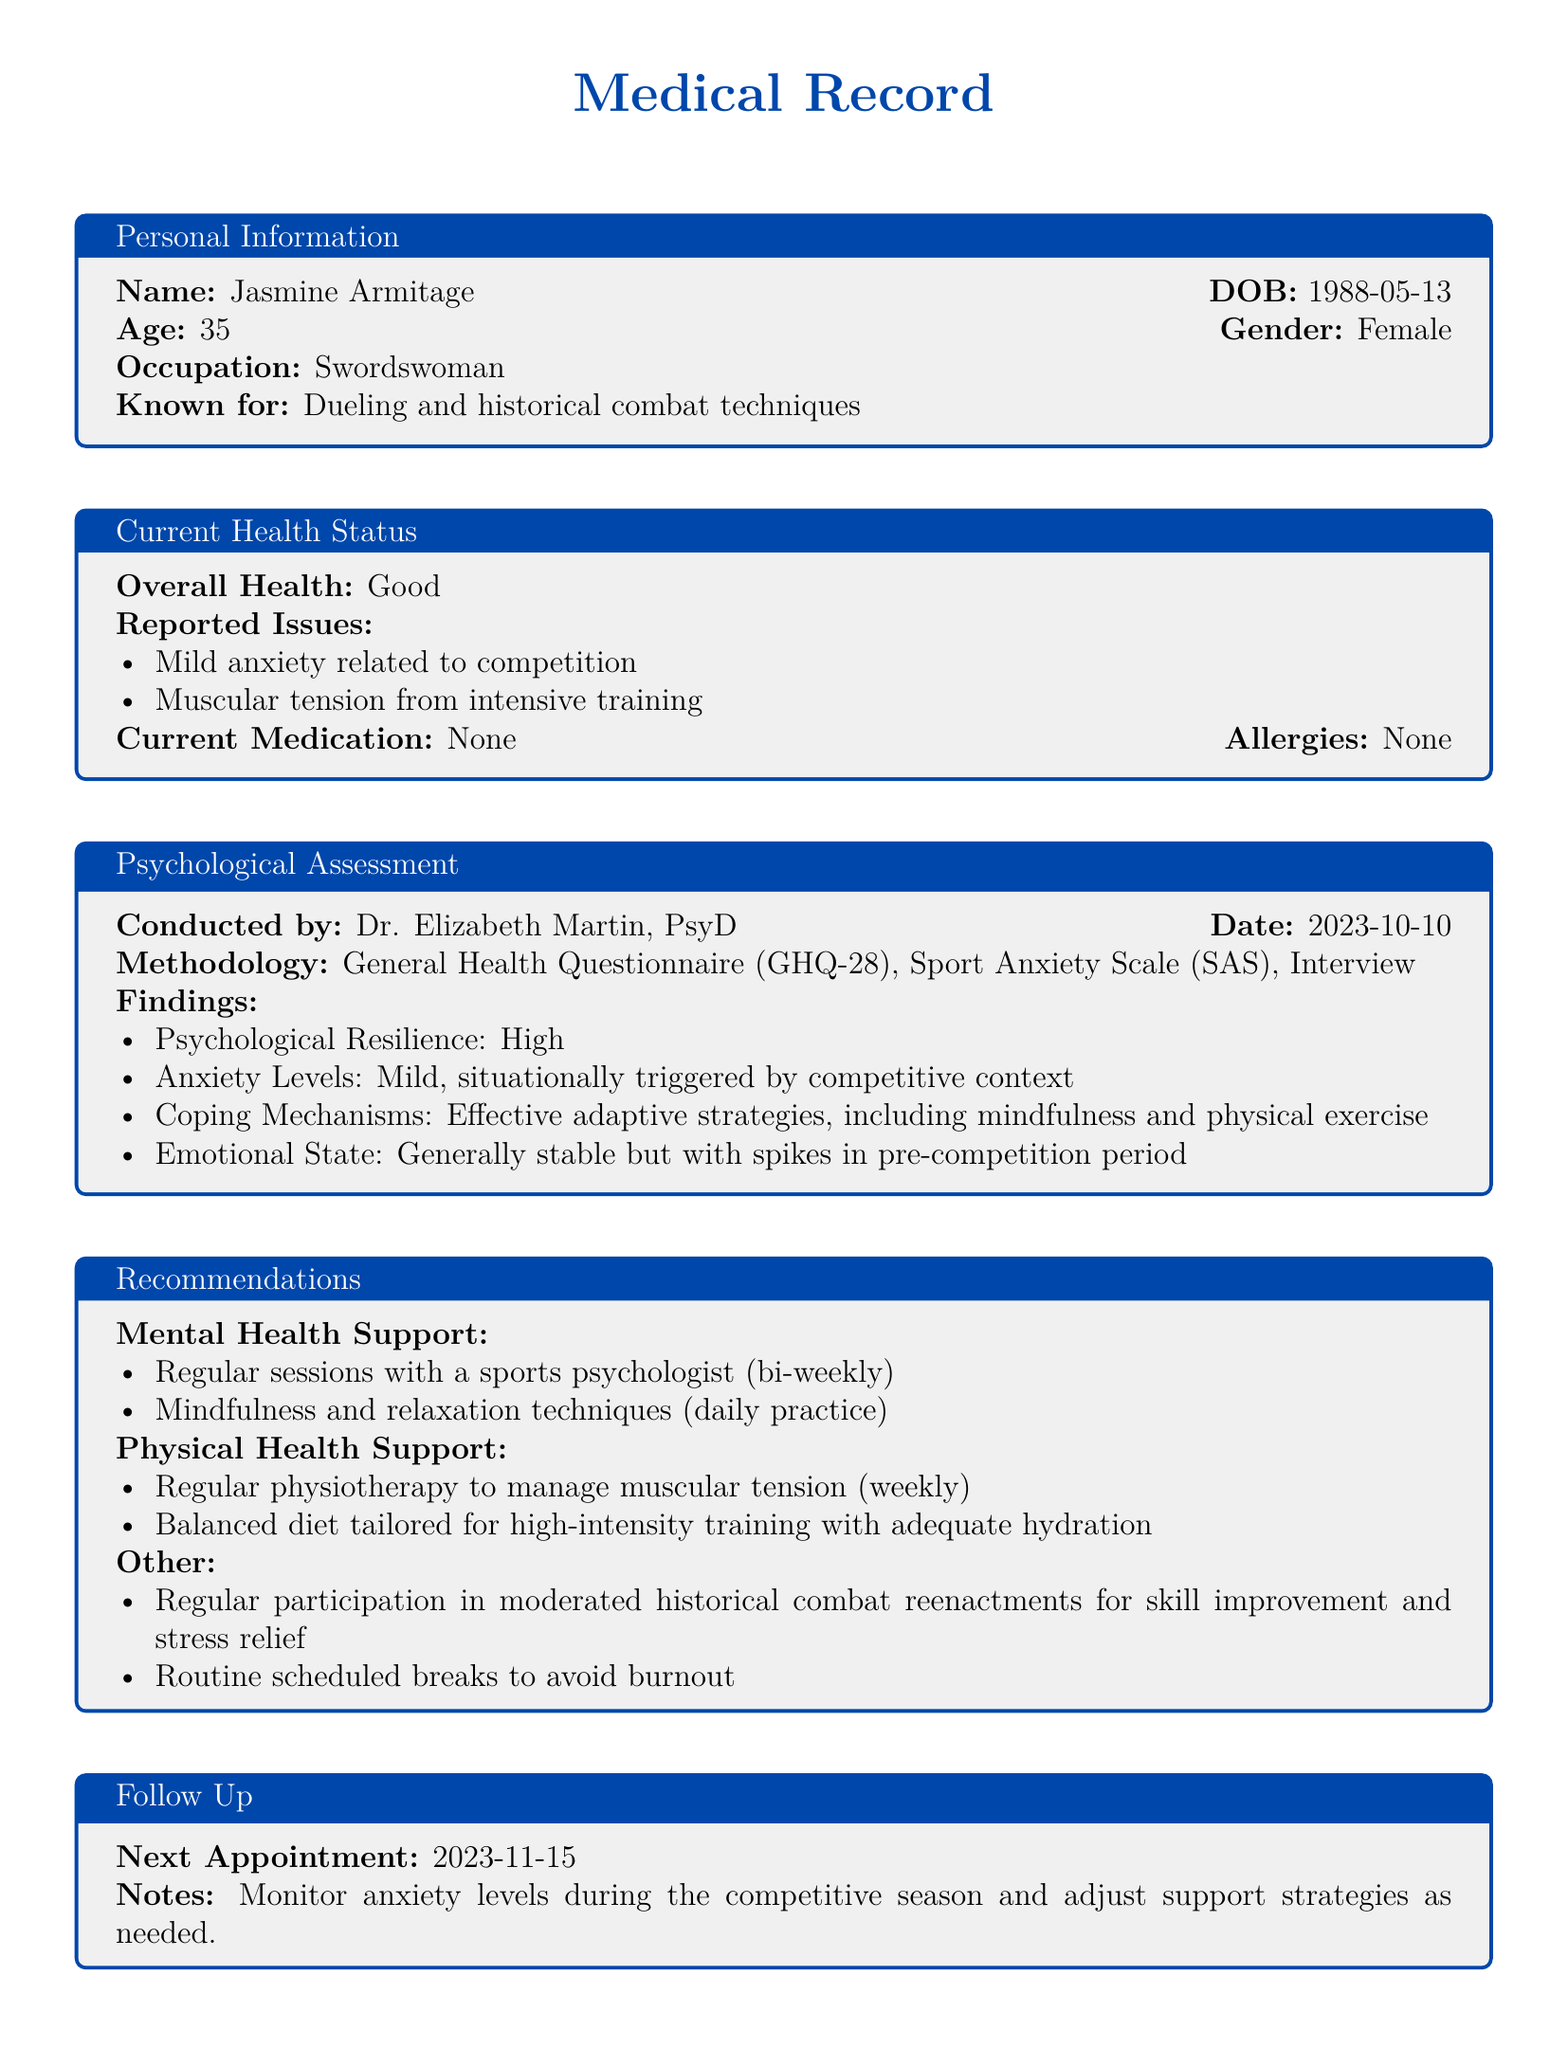What is the name of the patient? The name of the patient is listed in the personal information section of the document.
Answer: Jasmine Armitage What is the date of the psychological assessment? The date of the psychological assessment is provided under the Psychological Assessment section.
Answer: 2023-10-10 What are the reported issues from the patient's current health status? The reported issues are detailed in the Current Health Status section, which states the patient's concerns.
Answer: Mild anxiety related to competition, Muscular tension from intensive training How often is the patient recommended to meet with a sports psychologist? The recommendations section specifies the frequency of sessions with the sports psychologist.
Answer: Bi-weekly What is the emotional state of the patient described as? The emotional state can be found in the findings of the Psychological Assessment.
Answer: Generally stable but with spikes in pre-competition period What coping mechanisms does the patient use? The coping mechanisms are detailed in the Psychological Assessment findings section.
Answer: Effective adaptive strategies, including mindfulness and physical exercise When is the next appointment scheduled? The follow-up section indicates when the next appointment will take place.
Answer: 2023-11-15 What type of physiotherapy is recommended for the patient? The type of physiotherapy is mentioned in the Physical Health Support recommendations.
Answer: Regular physiotherapy to manage muscular tension What is the patient's overall health status? The overall health status is stated in the Current Health Status section.
Answer: Good 